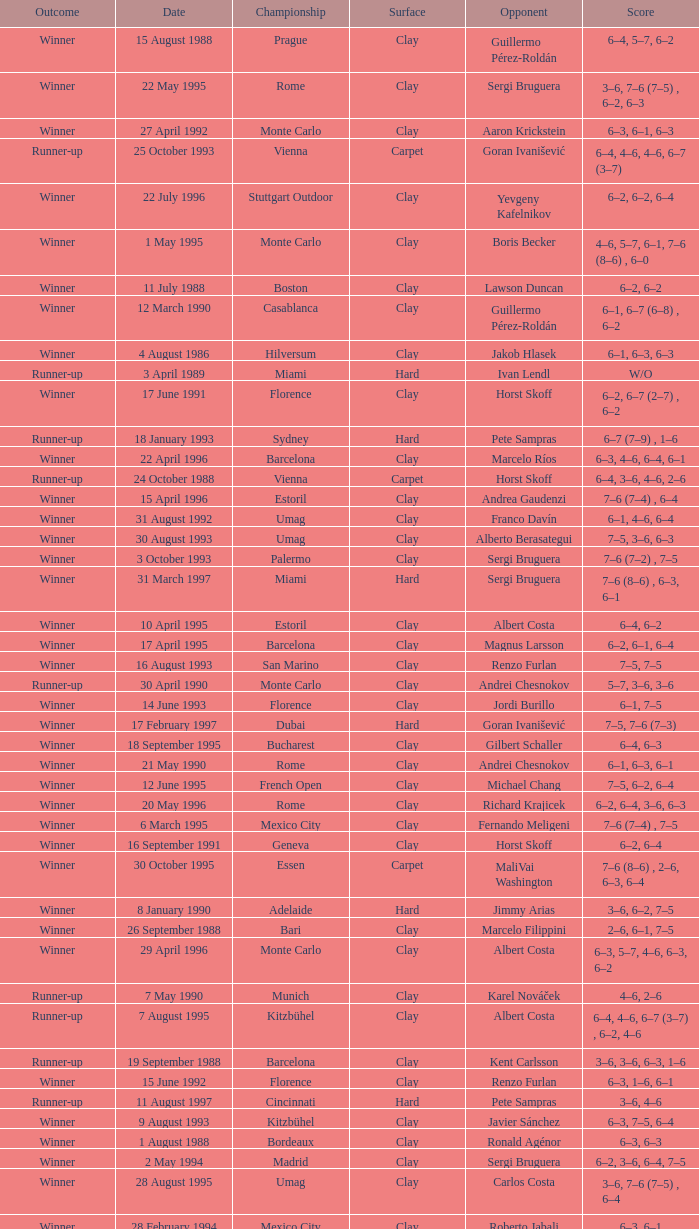What is the surface on 21 june 1993? Clay. 